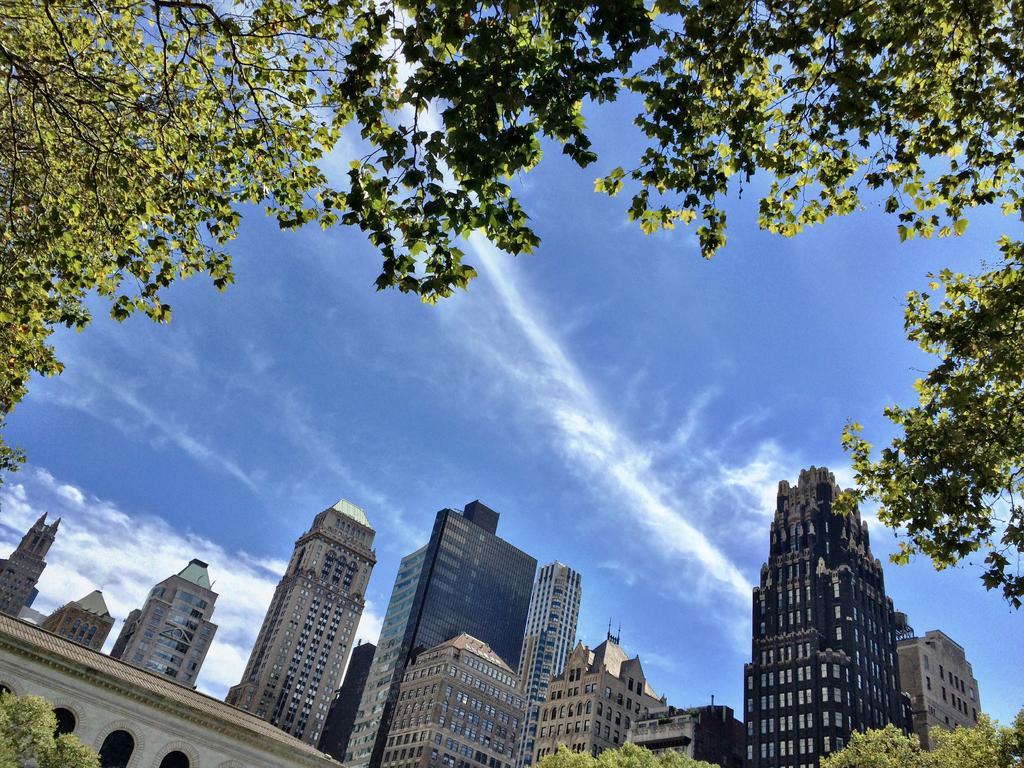Describe this image in one or two sentences. In this image we can see some buildings, windows, trees, plants, also we can see the sky. 